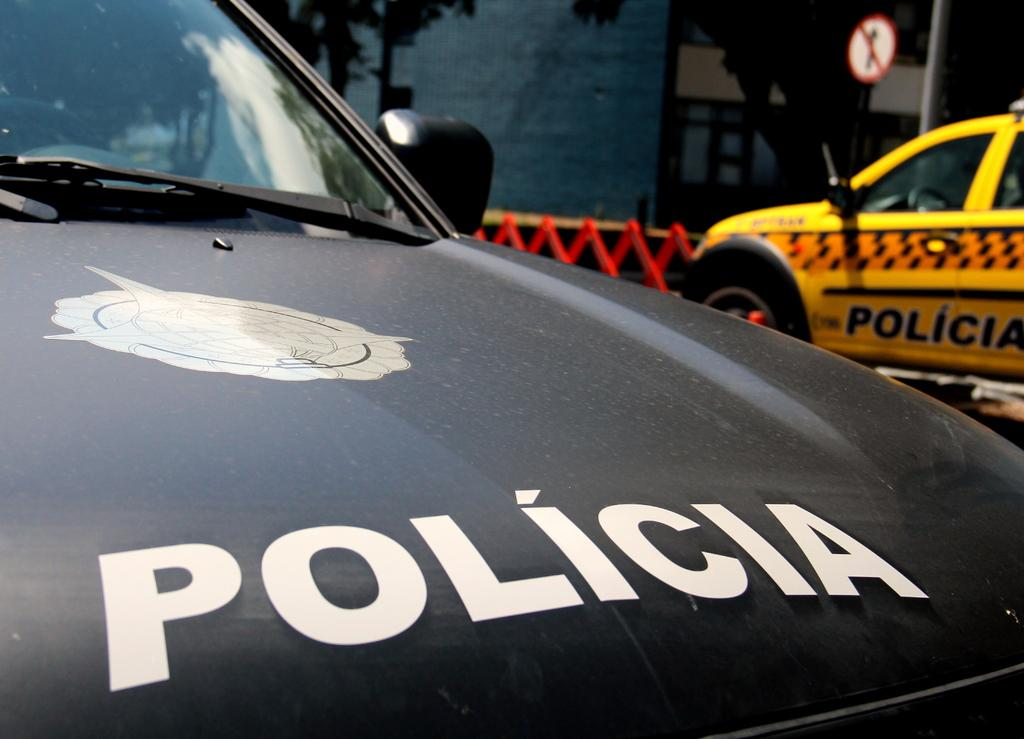<image>
Provide a brief description of the given image. The cars are both policia owned in another country. 